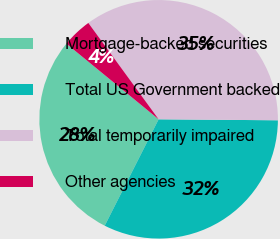Convert chart. <chart><loc_0><loc_0><loc_500><loc_500><pie_chart><fcel>Mortgage-backed securities<fcel>Total US Government backed<fcel>Total temporarily impaired<fcel>Other agencies<nl><fcel>28.46%<fcel>32.33%<fcel>35.16%<fcel>4.04%<nl></chart> 